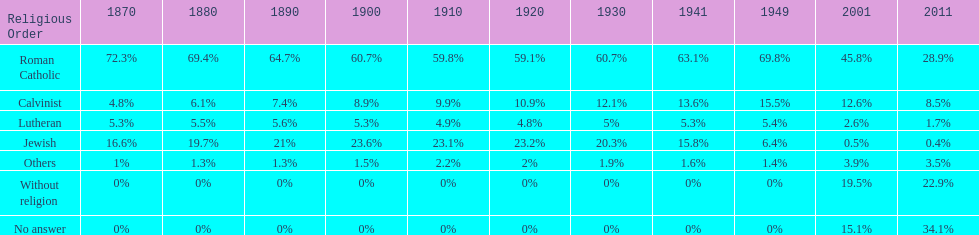Which denomination has the highest margin? Roman Catholic. 